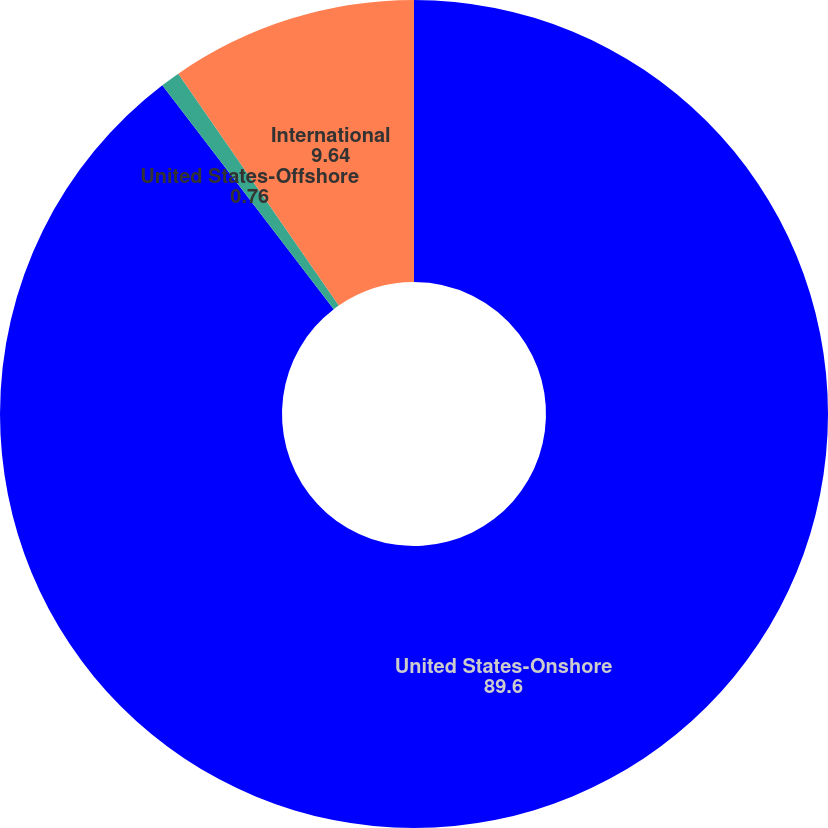<chart> <loc_0><loc_0><loc_500><loc_500><pie_chart><fcel>United States-Onshore<fcel>United States-Offshore<fcel>International<nl><fcel>89.6%<fcel>0.76%<fcel>9.64%<nl></chart> 